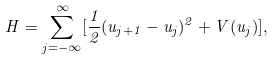Convert formula to latex. <formula><loc_0><loc_0><loc_500><loc_500>H = \sum _ { j = - \infty } ^ { \infty } [ \frac { 1 } { 2 } ( u _ { j + 1 } - u _ { j } ) ^ { 2 } + V ( u _ { j } ) ] ,</formula> 